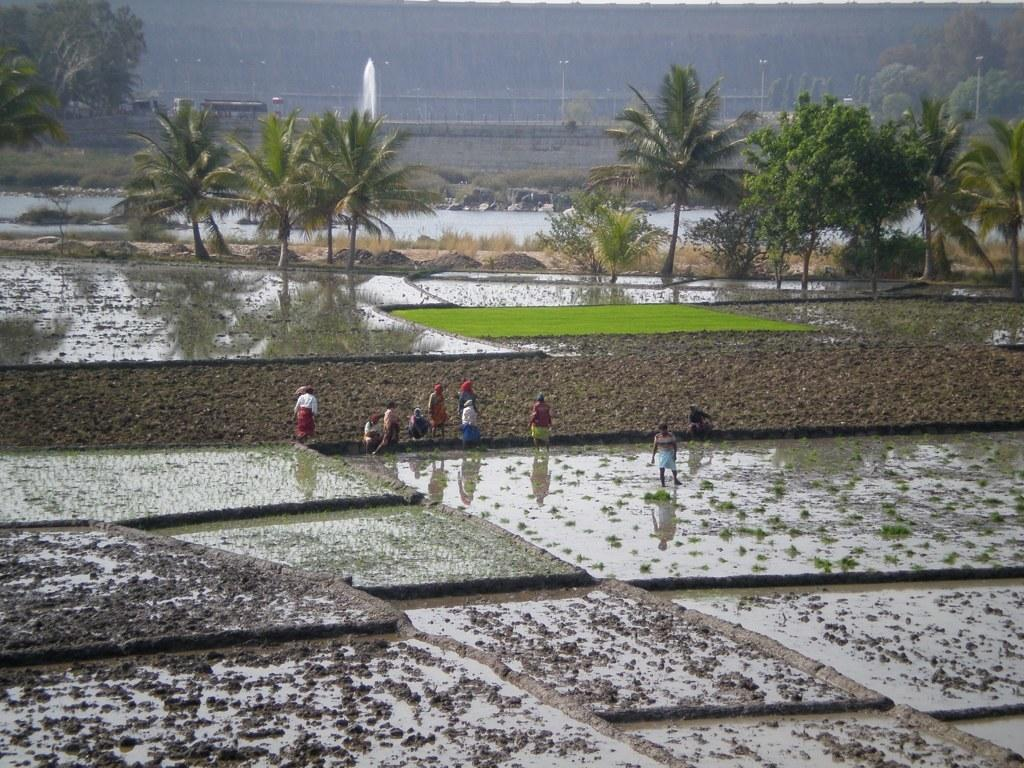What can be seen in the image in terms of human presence? There are people standing in the image. What type of landscape is visible in the image? There are fields, land, trees, and water visible in the image. What question is being asked by the people in the image? There is no indication in the image that a question is being asked by the people. Is there a fight happening in the image? There is no fight visible in the image; the people are standing calmly. 